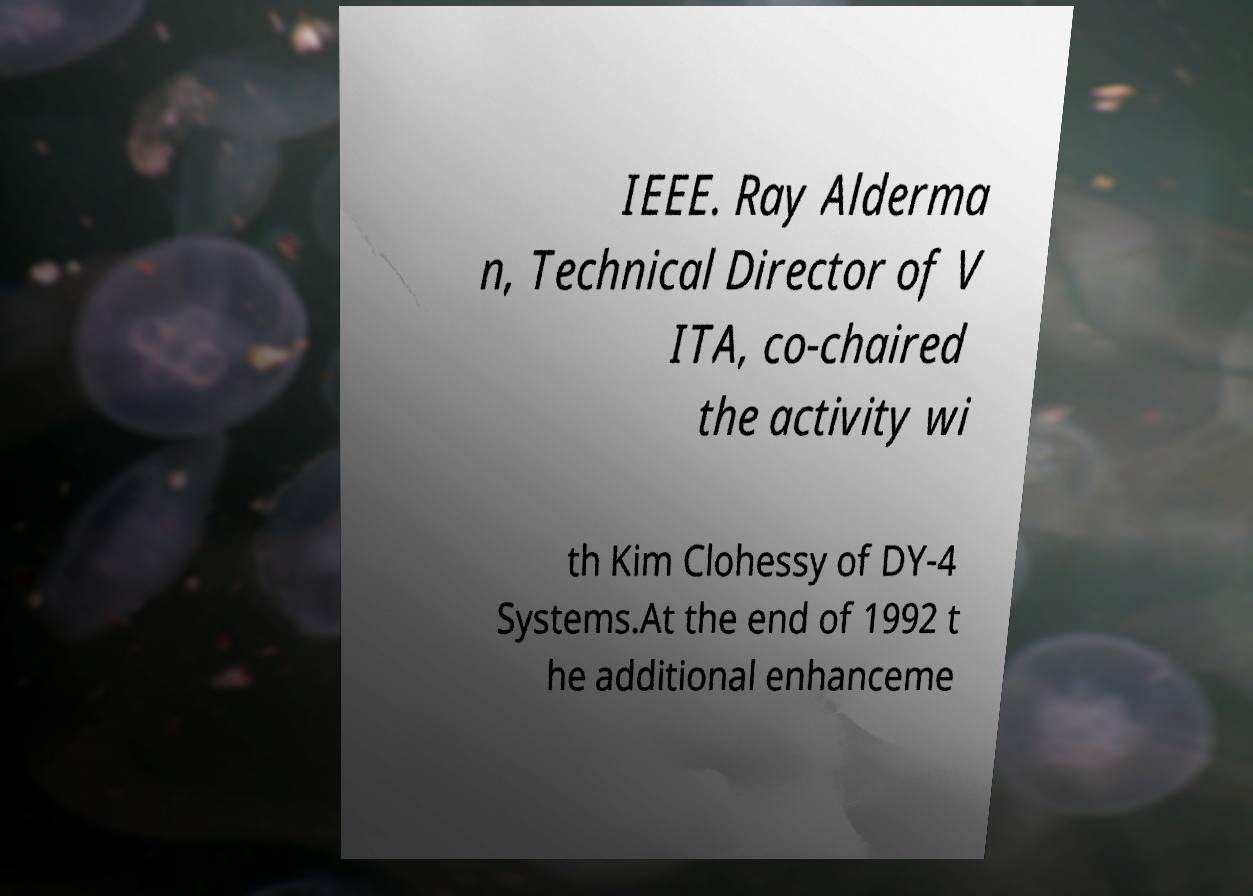Could you extract and type out the text from this image? IEEE. Ray Alderma n, Technical Director of V ITA, co-chaired the activity wi th Kim Clohessy of DY-4 Systems.At the end of 1992 t he additional enhanceme 